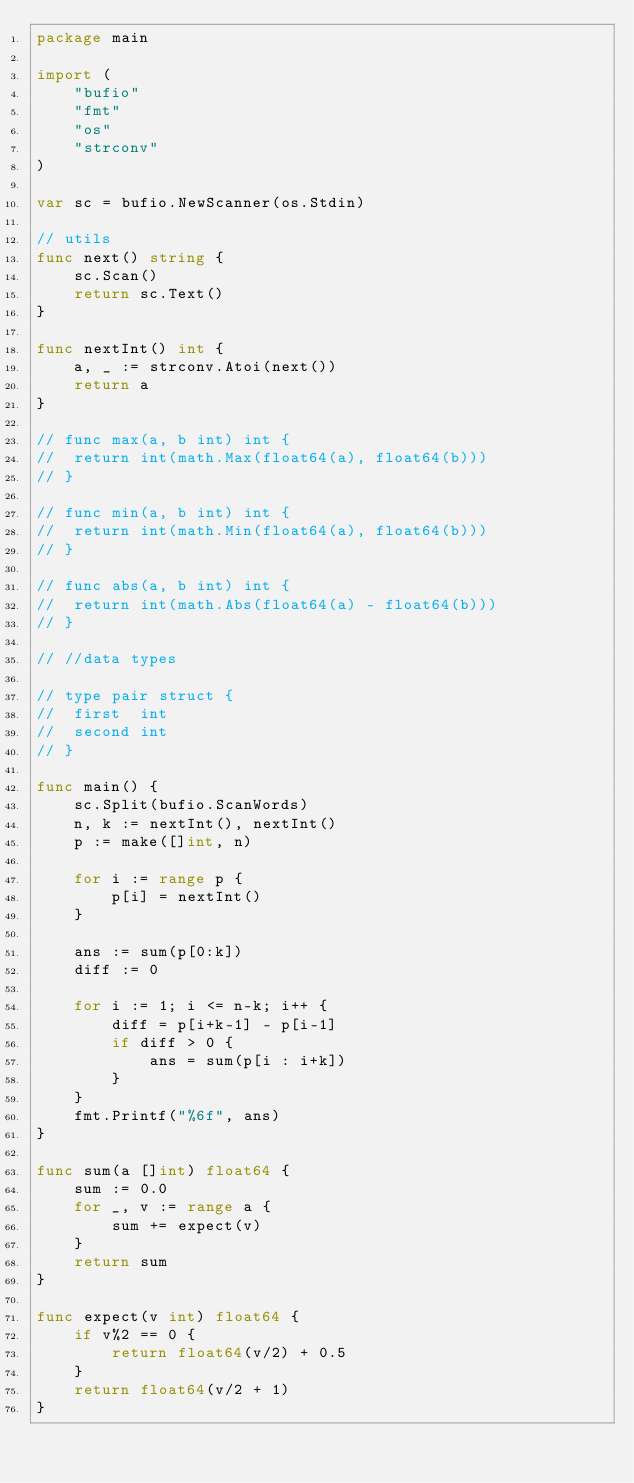Convert code to text. <code><loc_0><loc_0><loc_500><loc_500><_Go_>package main

import (
	"bufio"
	"fmt"
	"os"
	"strconv"
)

var sc = bufio.NewScanner(os.Stdin)

// utils
func next() string {
	sc.Scan()
	return sc.Text()
}

func nextInt() int {
	a, _ := strconv.Atoi(next())
	return a
}

// func max(a, b int) int {
// 	return int(math.Max(float64(a), float64(b)))
// }

// func min(a, b int) int {
// 	return int(math.Min(float64(a), float64(b)))
// }

// func abs(a, b int) int {
// 	return int(math.Abs(float64(a) - float64(b)))
// }

// //data types

// type pair struct {
// 	first  int
// 	second int
// }

func main() {
	sc.Split(bufio.ScanWords)
	n, k := nextInt(), nextInt()
	p := make([]int, n)

	for i := range p {
		p[i] = nextInt()
	}

	ans := sum(p[0:k])
	diff := 0

	for i := 1; i <= n-k; i++ {
		diff = p[i+k-1] - p[i-1]
		if diff > 0 {
			ans = sum(p[i : i+k])
		}
	}
	fmt.Printf("%6f", ans)
}

func sum(a []int) float64 {
	sum := 0.0
	for _, v := range a {
		sum += expect(v)
	}
	return sum
}

func expect(v int) float64 {
	if v%2 == 0 {
		return float64(v/2) + 0.5
	}
	return float64(v/2 + 1)
}
</code> 